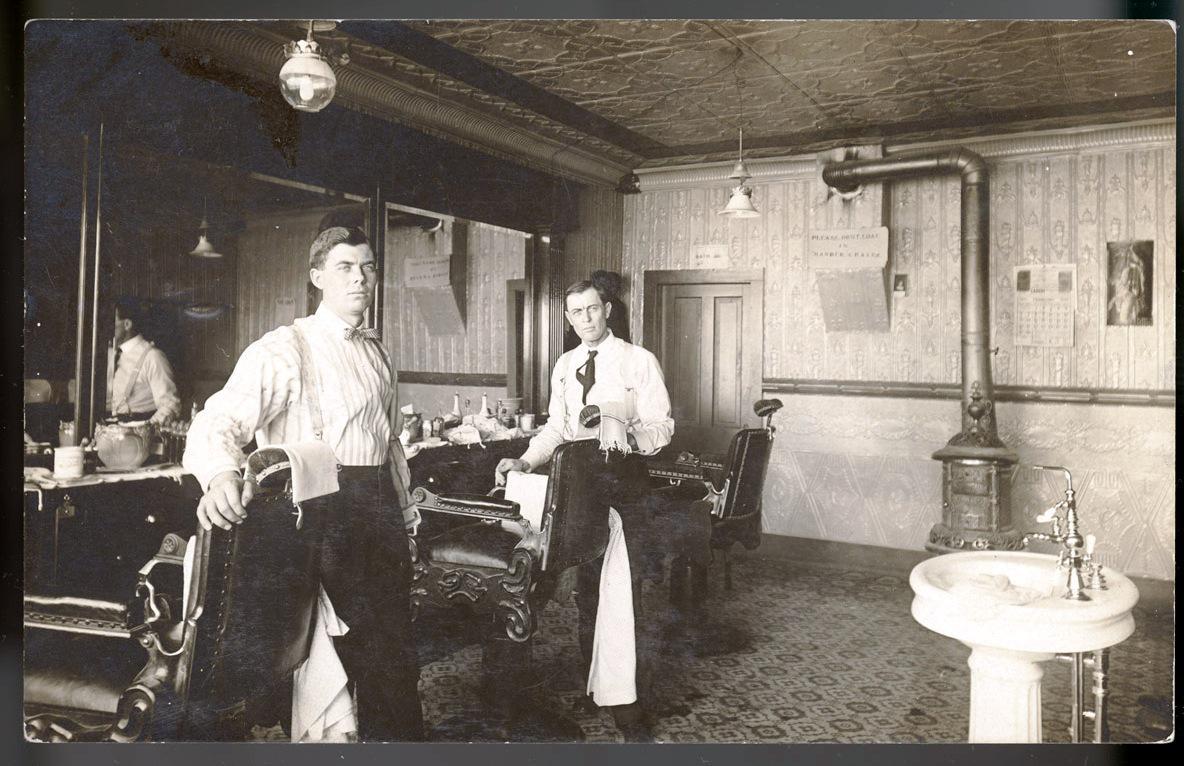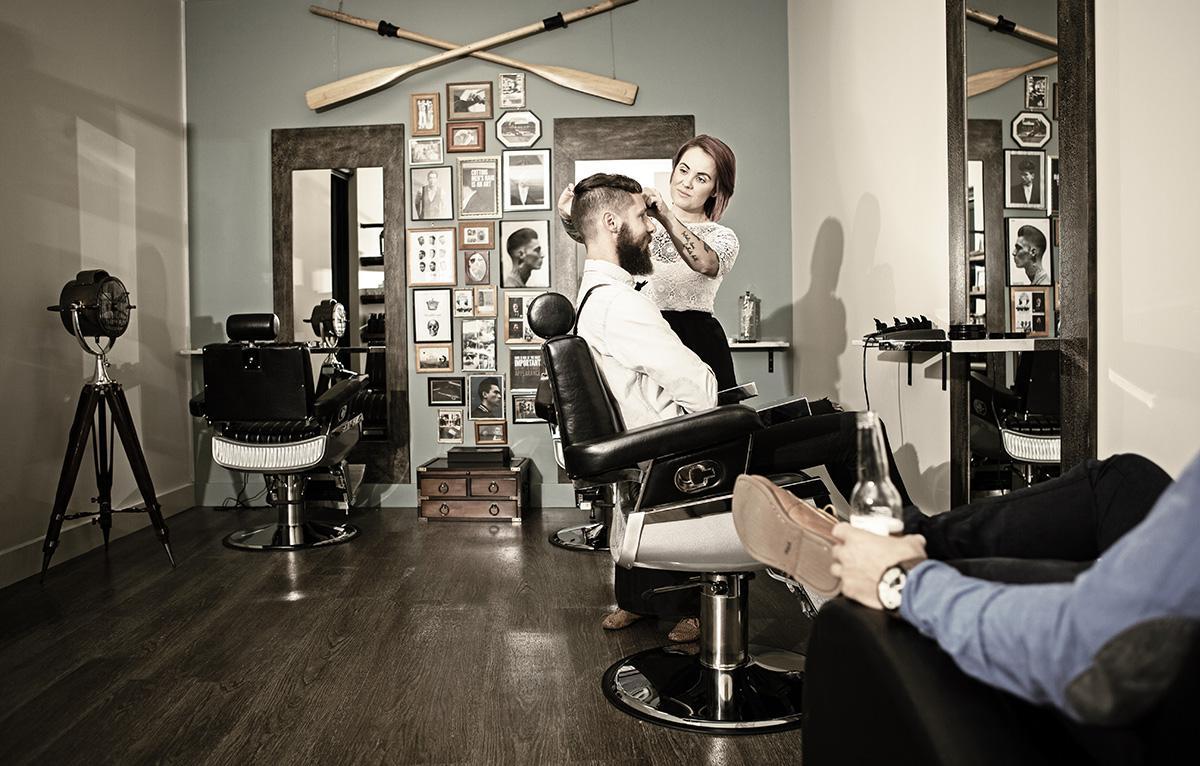The first image is the image on the left, the second image is the image on the right. Assess this claim about the two images: "In one image, one barber has a customer in his chair and one does not.". Correct or not? Answer yes or no. No. The first image is the image on the left, the second image is the image on the right. For the images displayed, is the sentence "THere are exactly two people in the image on the left." factually correct? Answer yes or no. Yes. 